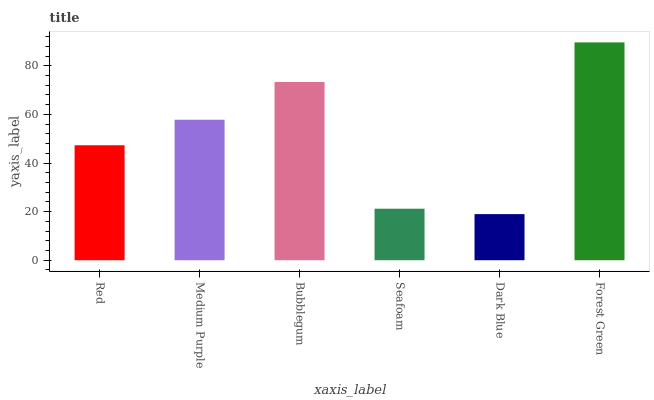Is Medium Purple the minimum?
Answer yes or no. No. Is Medium Purple the maximum?
Answer yes or no. No. Is Medium Purple greater than Red?
Answer yes or no. Yes. Is Red less than Medium Purple?
Answer yes or no. Yes. Is Red greater than Medium Purple?
Answer yes or no. No. Is Medium Purple less than Red?
Answer yes or no. No. Is Medium Purple the high median?
Answer yes or no. Yes. Is Red the low median?
Answer yes or no. Yes. Is Red the high median?
Answer yes or no. No. Is Medium Purple the low median?
Answer yes or no. No. 